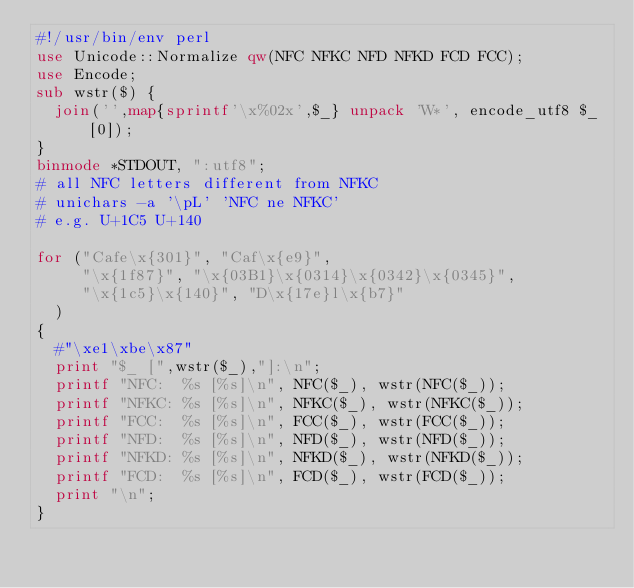<code> <loc_0><loc_0><loc_500><loc_500><_Perl_>#!/usr/bin/env perl
use Unicode::Normalize qw(NFC NFKC NFD NFKD FCD FCC);
use Encode;
sub wstr($) {
  join('',map{sprintf'\x%02x',$_} unpack 'W*', encode_utf8 $_[0]);
}
binmode *STDOUT, ":utf8";
# all NFC letters different from NFKC
# unichars -a '\pL' 'NFC ne NFKC'
# e.g. U+1C5 U+140

for ("Cafe\x{301}", "Caf\x{e9}",
     "\x{1f87}", "\x{03B1}\x{0314}\x{0342}\x{0345}",
     "\x{1c5}\x{140}", "D\x{17e}l\x{b7}"
  )
{
  #"\xe1\xbe\x87"
  print "$_ [",wstr($_),"]:\n";
  printf "NFC:  %s [%s]\n", NFC($_), wstr(NFC($_));
  printf "NFKC: %s [%s]\n", NFKC($_), wstr(NFKC($_));
  printf "FCC:  %s [%s]\n", FCC($_), wstr(FCC($_));
  printf "NFD:  %s [%s]\n", NFD($_), wstr(NFD($_));
  printf "NFKD: %s [%s]\n", NFKD($_), wstr(NFKD($_));
  printf "FCD:  %s [%s]\n", FCD($_), wstr(FCD($_));
  print "\n";
}
</code> 